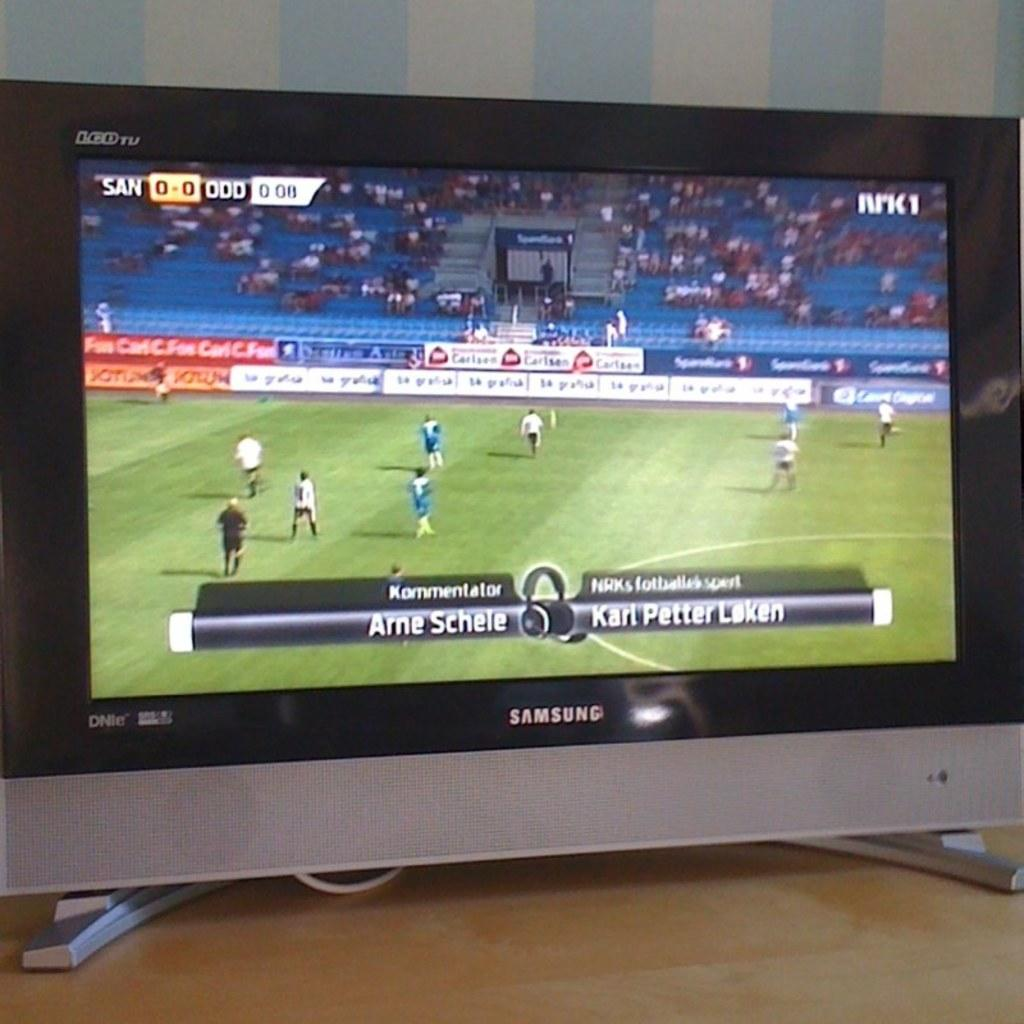<image>
Create a compact narrative representing the image presented. A Samsung brand TV plays a ball game. 